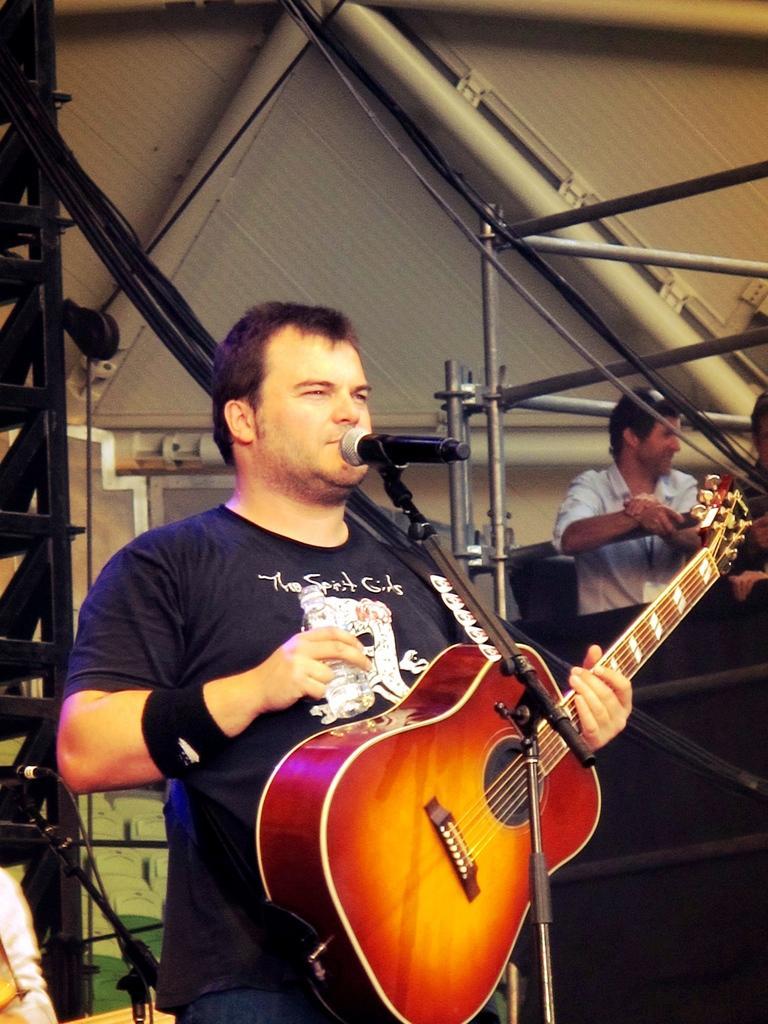Can you describe this image briefly? Here we can see one man standing in front of a mike and playing guitar. He wore wrist band. On the background we can see other person. 